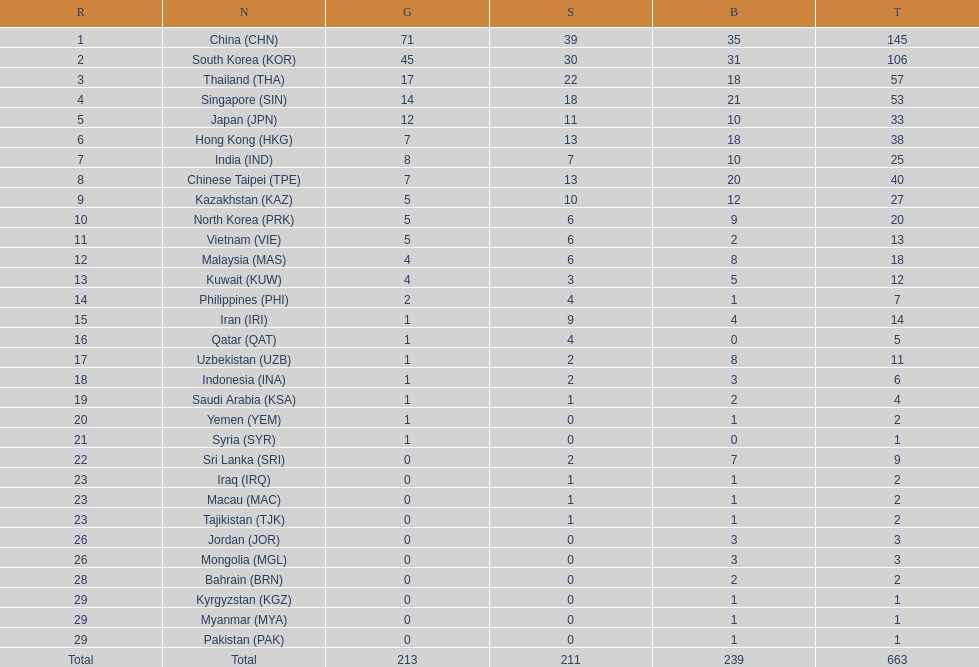Parse the table in full. {'header': ['R', 'N', 'G', 'S', 'B', 'T'], 'rows': [['1', 'China\xa0(CHN)', '71', '39', '35', '145'], ['2', 'South Korea\xa0(KOR)', '45', '30', '31', '106'], ['3', 'Thailand\xa0(THA)', '17', '22', '18', '57'], ['4', 'Singapore\xa0(SIN)', '14', '18', '21', '53'], ['5', 'Japan\xa0(JPN)', '12', '11', '10', '33'], ['6', 'Hong Kong\xa0(HKG)', '7', '13', '18', '38'], ['7', 'India\xa0(IND)', '8', '7', '10', '25'], ['8', 'Chinese Taipei\xa0(TPE)', '7', '13', '20', '40'], ['9', 'Kazakhstan\xa0(KAZ)', '5', '10', '12', '27'], ['10', 'North Korea\xa0(PRK)', '5', '6', '9', '20'], ['11', 'Vietnam\xa0(VIE)', '5', '6', '2', '13'], ['12', 'Malaysia\xa0(MAS)', '4', '6', '8', '18'], ['13', 'Kuwait\xa0(KUW)', '4', '3', '5', '12'], ['14', 'Philippines\xa0(PHI)', '2', '4', '1', '7'], ['15', 'Iran\xa0(IRI)', '1', '9', '4', '14'], ['16', 'Qatar\xa0(QAT)', '1', '4', '0', '5'], ['17', 'Uzbekistan\xa0(UZB)', '1', '2', '8', '11'], ['18', 'Indonesia\xa0(INA)', '1', '2', '3', '6'], ['19', 'Saudi Arabia\xa0(KSA)', '1', '1', '2', '4'], ['20', 'Yemen\xa0(YEM)', '1', '0', '1', '2'], ['21', 'Syria\xa0(SYR)', '1', '0', '0', '1'], ['22', 'Sri Lanka\xa0(SRI)', '0', '2', '7', '9'], ['23', 'Iraq\xa0(IRQ)', '0', '1', '1', '2'], ['23', 'Macau\xa0(MAC)', '0', '1', '1', '2'], ['23', 'Tajikistan\xa0(TJK)', '0', '1', '1', '2'], ['26', 'Jordan\xa0(JOR)', '0', '0', '3', '3'], ['26', 'Mongolia\xa0(MGL)', '0', '0', '3', '3'], ['28', 'Bahrain\xa0(BRN)', '0', '0', '2', '2'], ['29', 'Kyrgyzstan\xa0(KGZ)', '0', '0', '1', '1'], ['29', 'Myanmar\xa0(MYA)', '0', '0', '1', '1'], ['29', 'Pakistan\xa0(PAK)', '0', '0', '1', '1'], ['Total', 'Total', '213', '211', '239', '663']]} What is the difference between the total amount of medals won by qatar and indonesia? 1. 